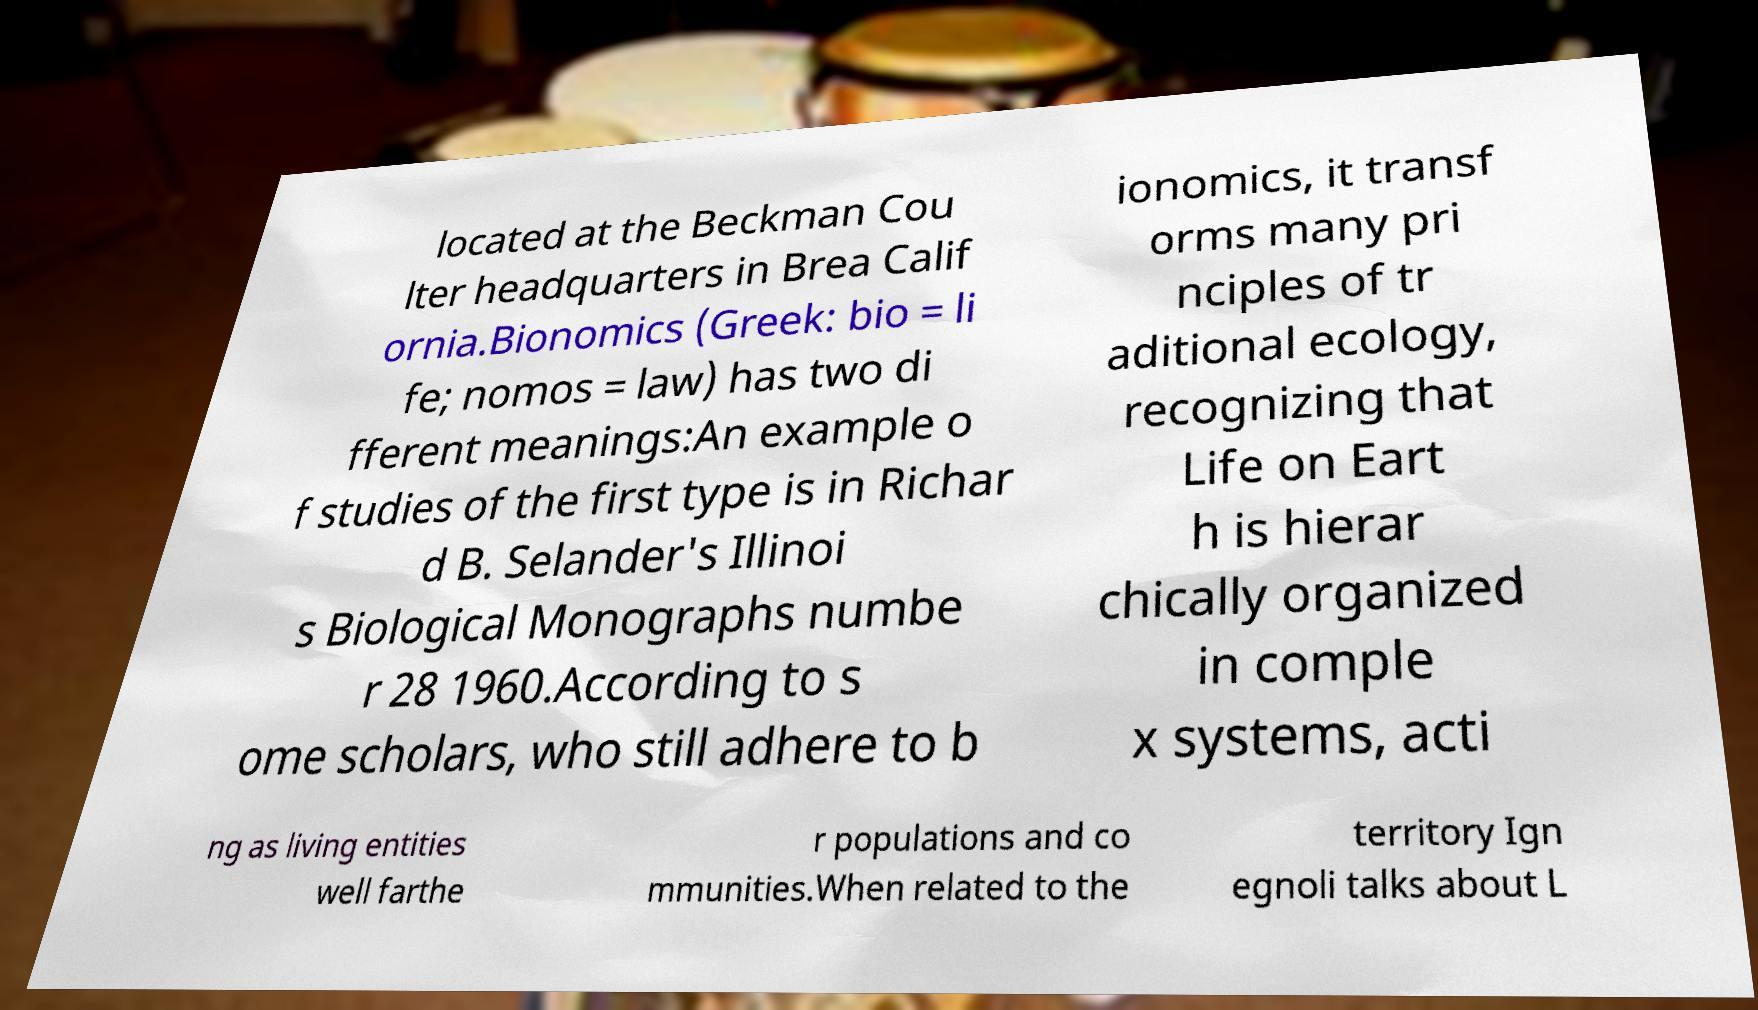Can you accurately transcribe the text from the provided image for me? located at the Beckman Cou lter headquarters in Brea Calif ornia.Bionomics (Greek: bio = li fe; nomos = law) has two di fferent meanings:An example o f studies of the first type is in Richar d B. Selander's Illinoi s Biological Monographs numbe r 28 1960.According to s ome scholars, who still adhere to b ionomics, it transf orms many pri nciples of tr aditional ecology, recognizing that Life on Eart h is hierar chically organized in comple x systems, acti ng as living entities well farthe r populations and co mmunities.When related to the territory Ign egnoli talks about L 